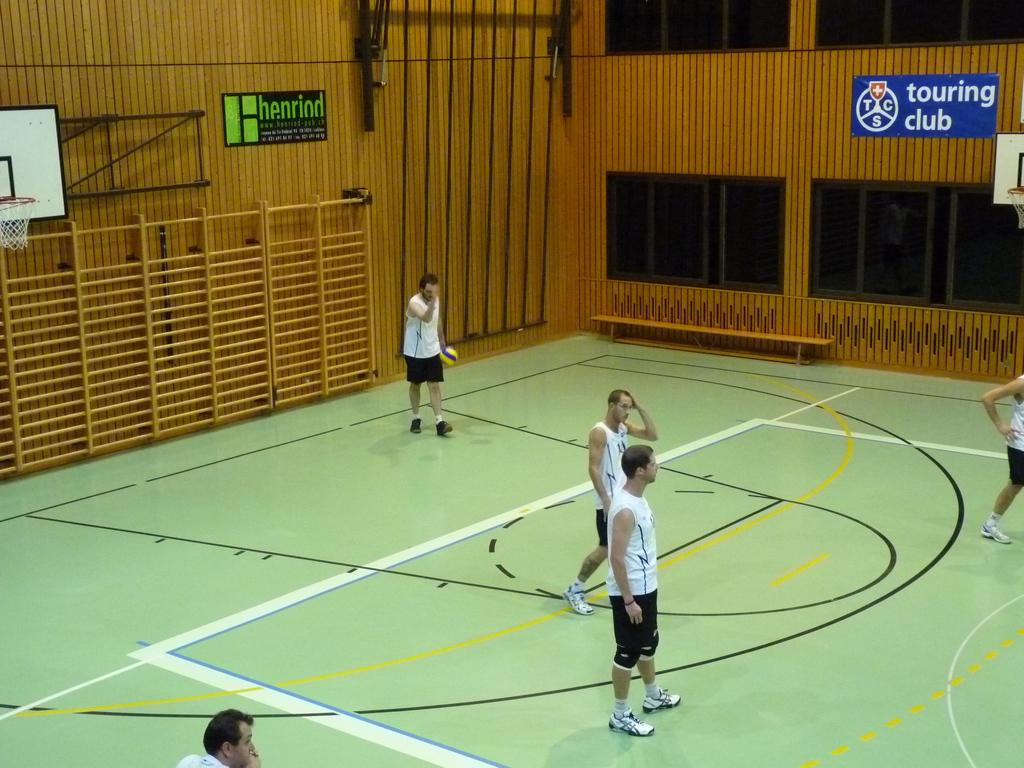<image>
Render a clear and concise summary of the photo. Several men are standing on a green, basketball court with posters on the wall around them advertising a touring club and henriod. 